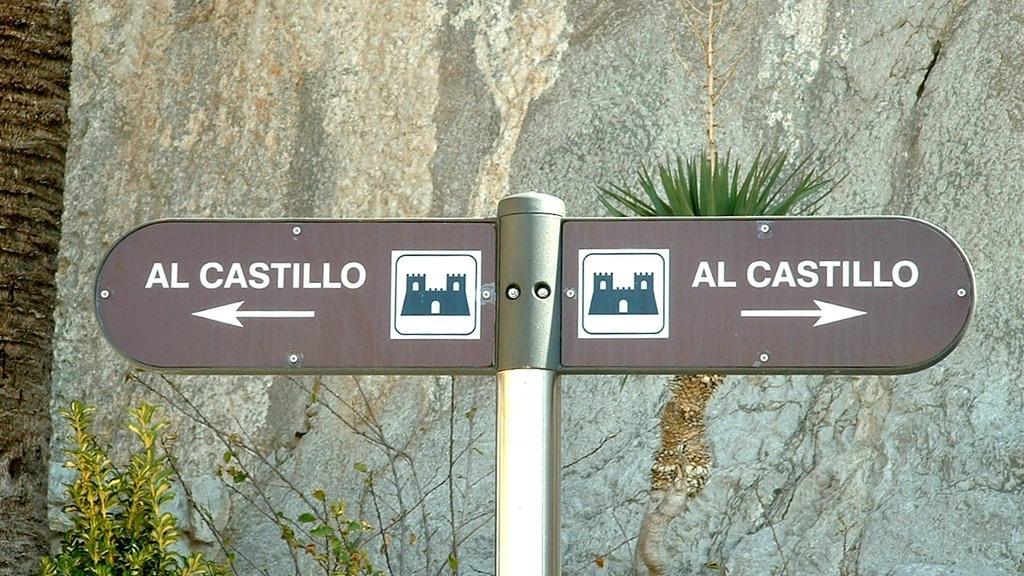Describe this image in one or two sentences. Here we can see a direction board on a pole. In the background there are plants,big rock and on the left side we can see a truncated tree. 